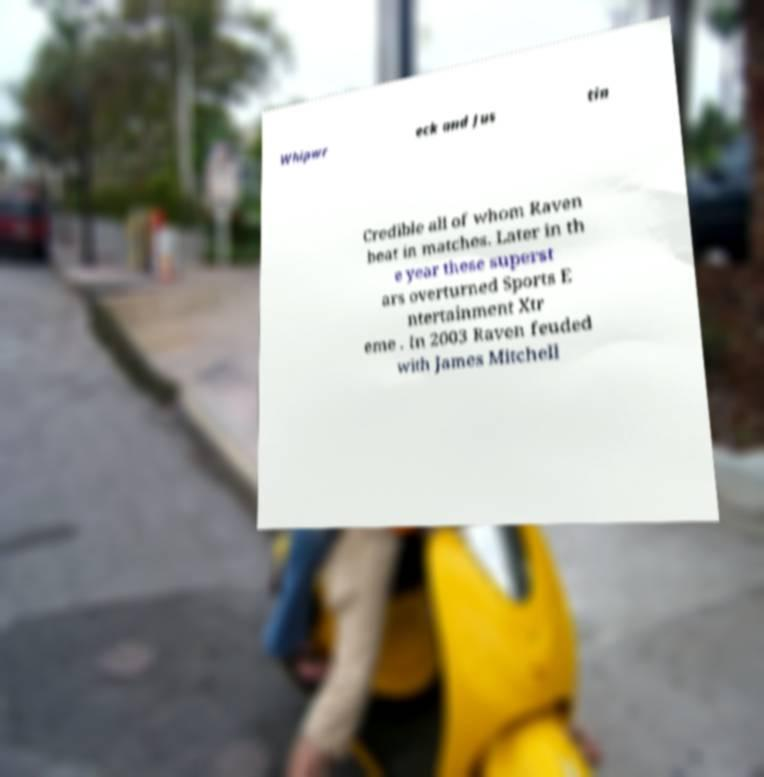I need the written content from this picture converted into text. Can you do that? Whipwr eck and Jus tin Credible all of whom Raven beat in matches. Later in th e year these superst ars overturned Sports E ntertainment Xtr eme . In 2003 Raven feuded with James Mitchell 